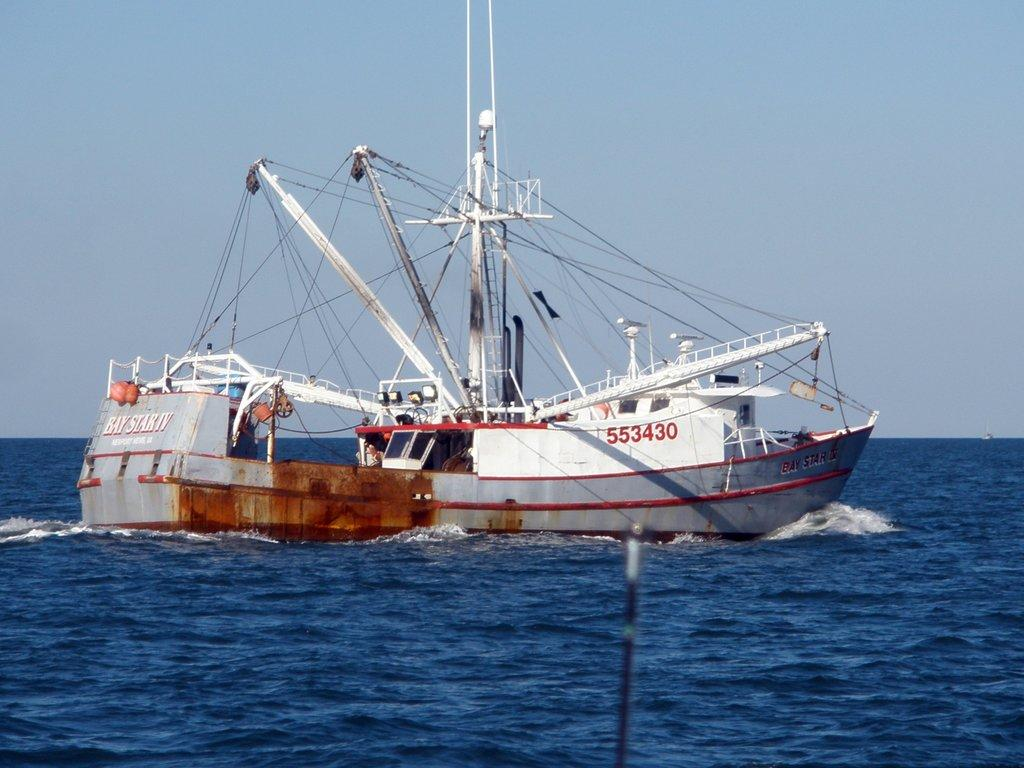What type of vehicles can be seen in the image? There are ships in the image. What structures are present in the image? There are poles in the image. What is at the bottom of the image? There is water at the bottom of the image. What is visible at the top of the image? The sky is visible at the top of the image. What type of setting is depicted in the image? The image appears to be taken in an ocean setting. Can you see any oil leaking from the ships in the image? There is no indication of oil leaking from the ships in the image. Is there a pig swimming in the water in the image? There is no pig present in the image; it features ships, poles, water, and the sky. 